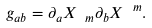<formula> <loc_0><loc_0><loc_500><loc_500>g _ { a b } = \partial _ { a } X _ { \ m } \partial _ { b } X ^ { \ m } .</formula> 